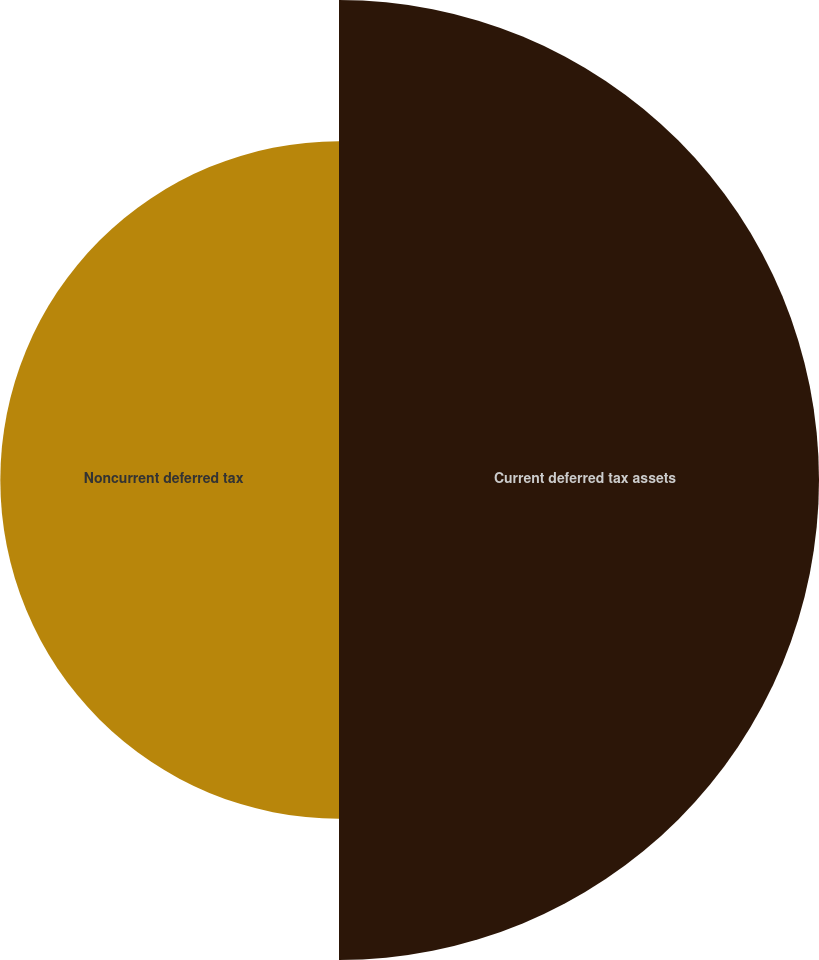<chart> <loc_0><loc_0><loc_500><loc_500><pie_chart><fcel>Current deferred tax assets<fcel>Noncurrent deferred tax<nl><fcel>58.63%<fcel>41.37%<nl></chart> 